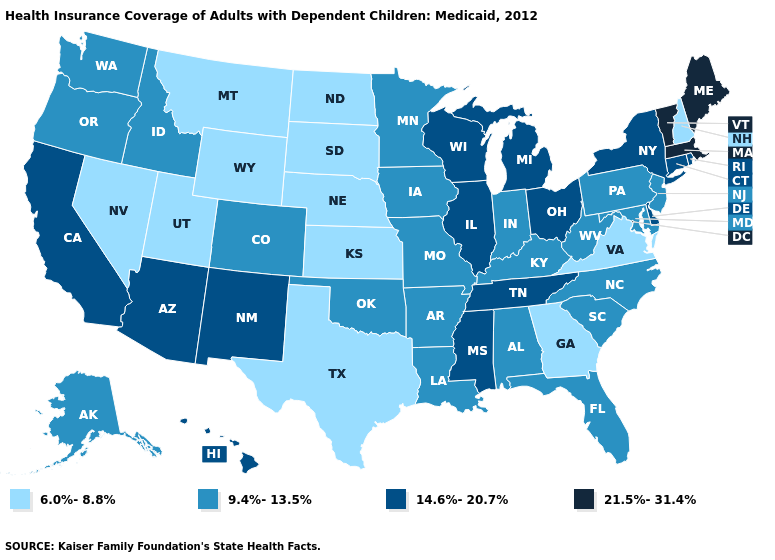Name the states that have a value in the range 21.5%-31.4%?
Write a very short answer. Maine, Massachusetts, Vermont. What is the value of Texas?
Give a very brief answer. 6.0%-8.8%. Which states have the lowest value in the West?
Be succinct. Montana, Nevada, Utah, Wyoming. What is the value of Michigan?
Answer briefly. 14.6%-20.7%. Does Mississippi have the highest value in the South?
Concise answer only. Yes. Does New Mexico have a higher value than Pennsylvania?
Write a very short answer. Yes. What is the value of Kansas?
Write a very short answer. 6.0%-8.8%. Is the legend a continuous bar?
Short answer required. No. What is the lowest value in the USA?
Keep it brief. 6.0%-8.8%. Among the states that border New Mexico , does Oklahoma have the highest value?
Concise answer only. No. What is the value of Utah?
Keep it brief. 6.0%-8.8%. Does Michigan have a lower value than Maine?
Keep it brief. Yes. Among the states that border Indiana , does Ohio have the highest value?
Keep it brief. Yes. Which states have the highest value in the USA?
Concise answer only. Maine, Massachusetts, Vermont. Name the states that have a value in the range 14.6%-20.7%?
Concise answer only. Arizona, California, Connecticut, Delaware, Hawaii, Illinois, Michigan, Mississippi, New Mexico, New York, Ohio, Rhode Island, Tennessee, Wisconsin. 